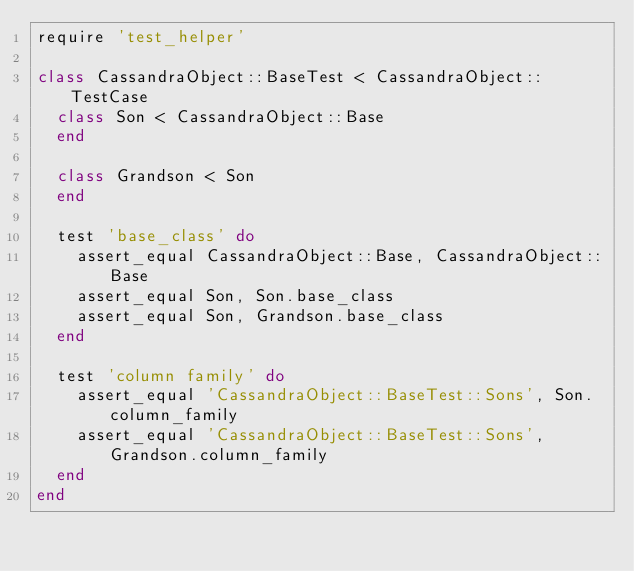Convert code to text. <code><loc_0><loc_0><loc_500><loc_500><_Ruby_>require 'test_helper'

class CassandraObject::BaseTest < CassandraObject::TestCase
  class Son < CassandraObject::Base
  end

  class Grandson < Son
  end

  test 'base_class' do
    assert_equal CassandraObject::Base, CassandraObject::Base
    assert_equal Son, Son.base_class
    assert_equal Son, Grandson.base_class
  end

  test 'column family' do
    assert_equal 'CassandraObject::BaseTest::Sons', Son.column_family
    assert_equal 'CassandraObject::BaseTest::Sons', Grandson.column_family
  end
end
</code> 